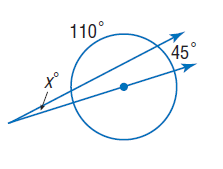Answer the mathemtical geometry problem and directly provide the correct option letter.
Question: Find x. Assume that segments that appear to be tangent are tangent.
Choices: A: 10 B: 20 C: 45 D: 110 A 